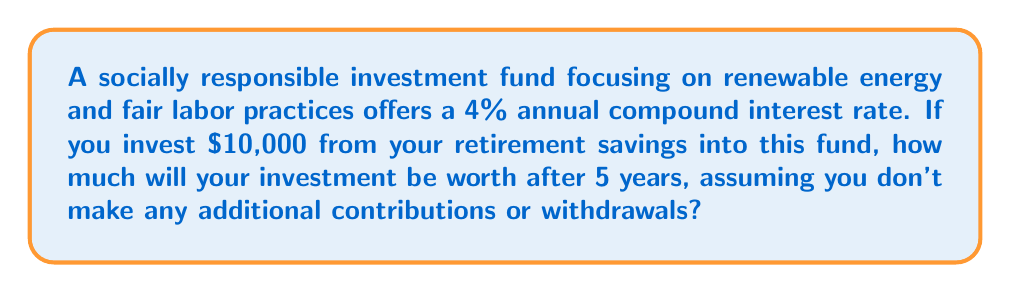Solve this math problem. To solve this problem, we'll use the compound interest formula:

$$ A = P(1 + r)^n $$

Where:
$A$ = Final amount
$P$ = Principal (initial investment)
$r$ = Annual interest rate (as a decimal)
$n$ = Number of years

Given:
$P = $10,000$
$r = 4\% = 0.04$
$n = 5$ years

Let's plug these values into the formula:

$$ A = 10000(1 + 0.04)^5 $$

Now, let's calculate step by step:

1) First, add 1 to the interest rate:
   $1 + 0.04 = 1.04$

2) Then, raise this to the power of 5:
   $1.04^5 \approx 1.2166529024$

3) Finally, multiply by the principal:
   $10000 \times 1.2166529024 = 12166.529024$

Therefore, after 5 years, the investment will be worth $12,166.53 (rounded to the nearest cent).
Answer: $12,166.53 